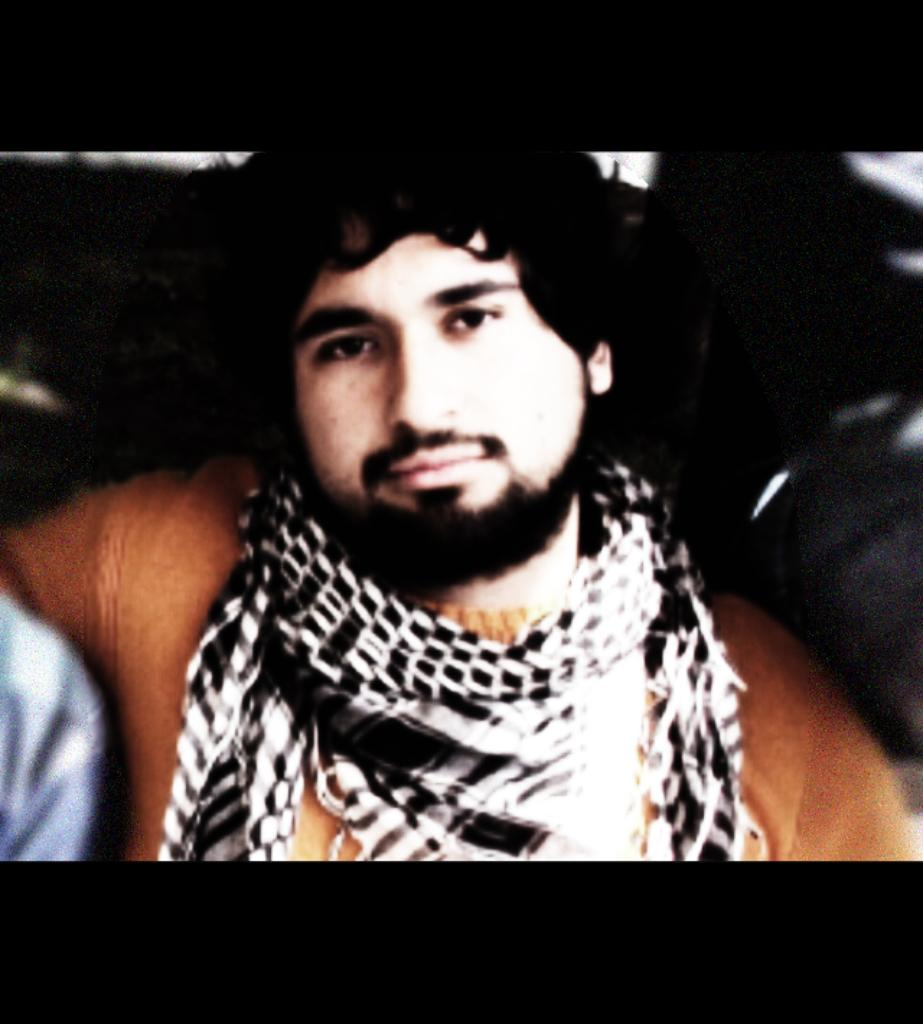Who is present in the image? There is a man in the image. What is the man wearing on his upper body? The man is wearing a brown t-shirt. What accessory is the man wearing around his neck? The man is wearing a black scarf. What can be observed about the background of the image? The background of the image is dark. What type of pan is the man using to cook in the image? There is no pan or cooking activity present in the image. How many bears can be seen interacting with the man in the image? There are no bears present in the image. 